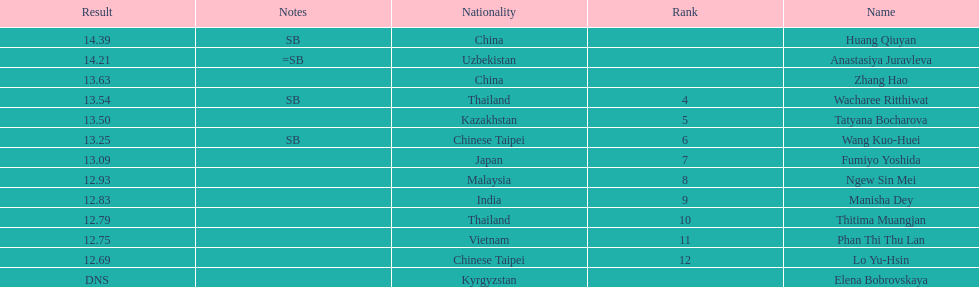What is the number of different nationalities represented by the top 5 athletes? 4. 